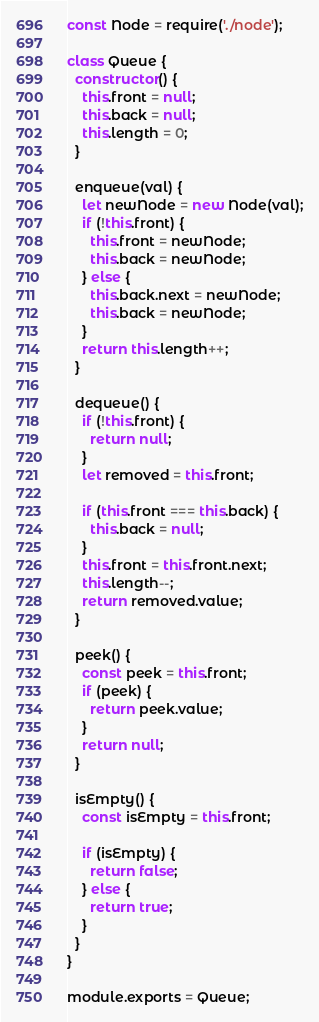Convert code to text. <code><loc_0><loc_0><loc_500><loc_500><_JavaScript_>const Node = require('./node');

class Queue {
  constructor() {
    this.front = null;
    this.back = null;
    this.length = 0;
  }

  enqueue(val) {
    let newNode = new Node(val);
    if (!this.front) {
      this.front = newNode;
      this.back = newNode;
    } else {
      this.back.next = newNode;
      this.back = newNode;
    }
    return this.length++;
  }

  dequeue() {
    if (!this.front) {
      return null;
    }
    let removed = this.front;

    if (this.front === this.back) {
      this.back = null;
    }
    this.front = this.front.next;
    this.length--;
    return removed.value;
  }

  peek() {
    const peek = this.front;
    if (peek) {
      return peek.value;
    }
    return null;
  }

  isEmpty() {
    const isEmpty = this.front;

    if (isEmpty) {
      return false;
    } else {
      return true;
    }
  }
}

module.exports = Queue;
</code> 